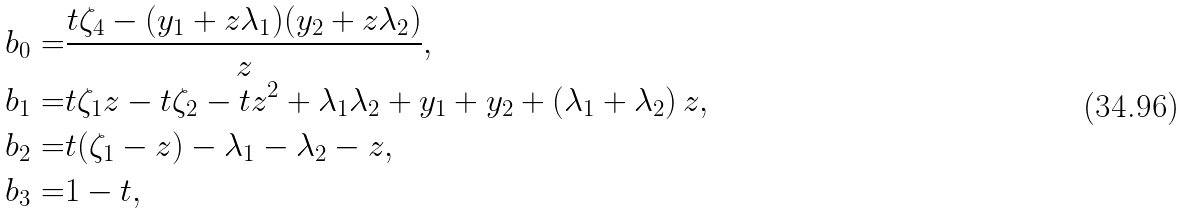Convert formula to latex. <formula><loc_0><loc_0><loc_500><loc_500>b _ { 0 } = & \frac { t \zeta _ { 4 } - ( y _ { 1 } + z \lambda _ { 1 } ) ( y _ { 2 } + z \lambda _ { 2 } ) } { z } , \\ b _ { 1 } = & t \zeta _ { 1 } z - t \zeta _ { 2 } - t z ^ { 2 } + \lambda _ { 1 } \lambda _ { 2 } + y _ { 1 } + y _ { 2 } + \left ( \lambda _ { 1 } + \lambda _ { 2 } \right ) z , \\ b _ { 2 } = & t ( \zeta _ { 1 } - z ) - \lambda _ { 1 } - \lambda _ { 2 } - z , \\ b _ { 3 } = & 1 - t ,</formula> 